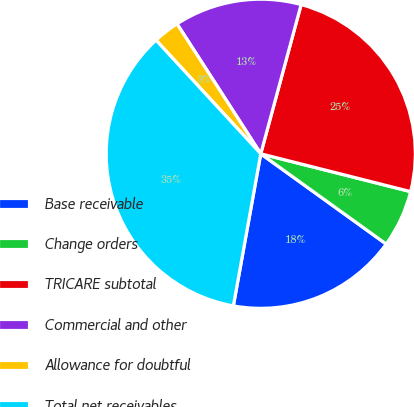Convert chart to OTSL. <chart><loc_0><loc_0><loc_500><loc_500><pie_chart><fcel>Base receivable<fcel>Change orders<fcel>TRICARE subtotal<fcel>Commercial and other<fcel>Allowance for doubtful<fcel>Total net receivables<nl><fcel>17.91%<fcel>5.99%<fcel>24.73%<fcel>13.32%<fcel>2.74%<fcel>35.31%<nl></chart> 